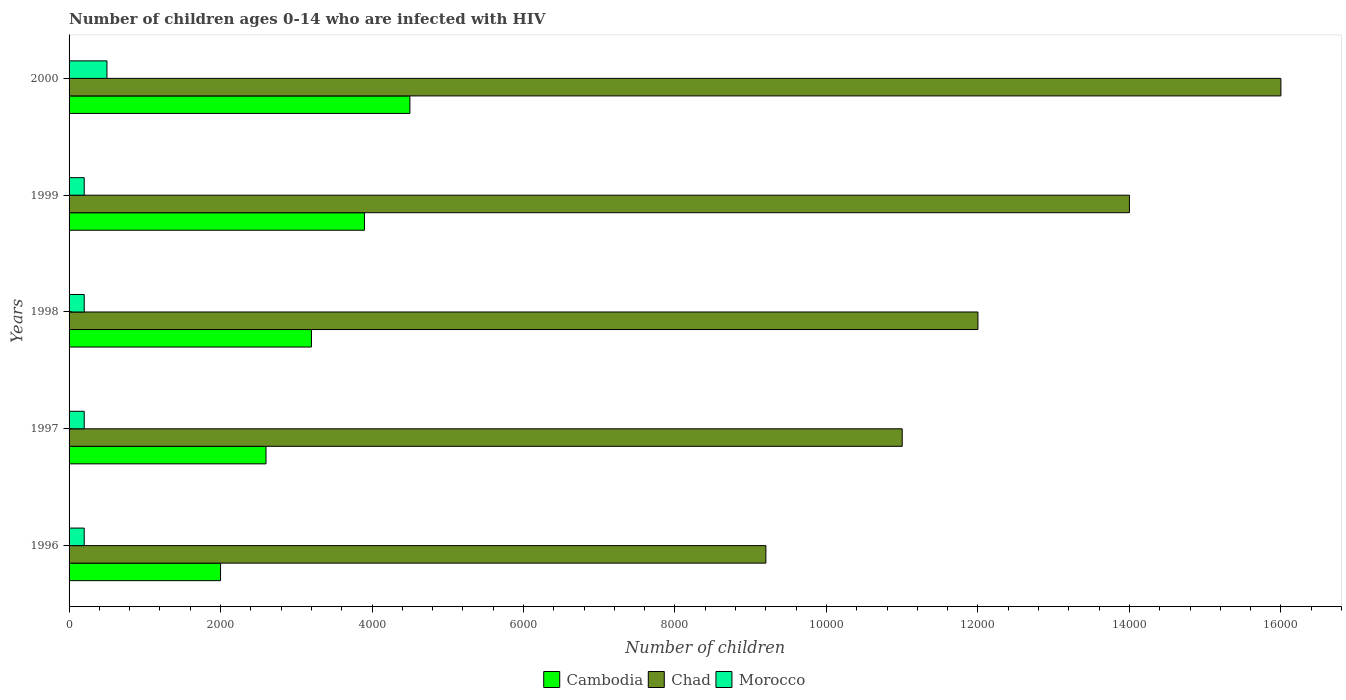How many different coloured bars are there?
Keep it short and to the point. 3. Are the number of bars per tick equal to the number of legend labels?
Ensure brevity in your answer.  Yes. How many bars are there on the 4th tick from the top?
Provide a succinct answer. 3. What is the number of HIV infected children in Morocco in 1999?
Make the answer very short. 200. Across all years, what is the maximum number of HIV infected children in Morocco?
Your response must be concise. 500. Across all years, what is the minimum number of HIV infected children in Chad?
Offer a terse response. 9200. In which year was the number of HIV infected children in Morocco maximum?
Offer a very short reply. 2000. In which year was the number of HIV infected children in Morocco minimum?
Ensure brevity in your answer.  1996. What is the total number of HIV infected children in Cambodia in the graph?
Offer a terse response. 1.62e+04. What is the difference between the number of HIV infected children in Cambodia in 1998 and that in 2000?
Keep it short and to the point. -1300. What is the difference between the number of HIV infected children in Cambodia in 1996 and the number of HIV infected children in Morocco in 2000?
Your answer should be very brief. 1500. What is the average number of HIV infected children in Cambodia per year?
Your answer should be compact. 3240. In the year 1999, what is the difference between the number of HIV infected children in Morocco and number of HIV infected children in Chad?
Your response must be concise. -1.38e+04. What is the difference between the highest and the lowest number of HIV infected children in Cambodia?
Ensure brevity in your answer.  2500. Is the sum of the number of HIV infected children in Morocco in 1998 and 1999 greater than the maximum number of HIV infected children in Cambodia across all years?
Provide a short and direct response. No. What does the 1st bar from the top in 1996 represents?
Your answer should be compact. Morocco. What does the 3rd bar from the bottom in 2000 represents?
Offer a very short reply. Morocco. What is the difference between two consecutive major ticks on the X-axis?
Your response must be concise. 2000. Are the values on the major ticks of X-axis written in scientific E-notation?
Offer a very short reply. No. Does the graph contain any zero values?
Offer a terse response. No. How many legend labels are there?
Make the answer very short. 3. How are the legend labels stacked?
Provide a succinct answer. Horizontal. What is the title of the graph?
Provide a short and direct response. Number of children ages 0-14 who are infected with HIV. What is the label or title of the X-axis?
Provide a short and direct response. Number of children. What is the Number of children of Cambodia in 1996?
Offer a very short reply. 2000. What is the Number of children of Chad in 1996?
Your response must be concise. 9200. What is the Number of children of Morocco in 1996?
Provide a short and direct response. 200. What is the Number of children of Cambodia in 1997?
Provide a succinct answer. 2600. What is the Number of children in Chad in 1997?
Your answer should be very brief. 1.10e+04. What is the Number of children of Cambodia in 1998?
Your response must be concise. 3200. What is the Number of children in Chad in 1998?
Give a very brief answer. 1.20e+04. What is the Number of children in Morocco in 1998?
Provide a short and direct response. 200. What is the Number of children in Cambodia in 1999?
Provide a succinct answer. 3900. What is the Number of children in Chad in 1999?
Your answer should be very brief. 1.40e+04. What is the Number of children of Morocco in 1999?
Offer a very short reply. 200. What is the Number of children in Cambodia in 2000?
Offer a very short reply. 4500. What is the Number of children in Chad in 2000?
Provide a short and direct response. 1.60e+04. Across all years, what is the maximum Number of children in Cambodia?
Make the answer very short. 4500. Across all years, what is the maximum Number of children of Chad?
Your answer should be very brief. 1.60e+04. Across all years, what is the minimum Number of children of Chad?
Offer a very short reply. 9200. Across all years, what is the minimum Number of children in Morocco?
Offer a terse response. 200. What is the total Number of children of Cambodia in the graph?
Offer a very short reply. 1.62e+04. What is the total Number of children of Chad in the graph?
Your response must be concise. 6.22e+04. What is the total Number of children of Morocco in the graph?
Provide a short and direct response. 1300. What is the difference between the Number of children in Cambodia in 1996 and that in 1997?
Offer a terse response. -600. What is the difference between the Number of children of Chad in 1996 and that in 1997?
Keep it short and to the point. -1800. What is the difference between the Number of children of Cambodia in 1996 and that in 1998?
Offer a very short reply. -1200. What is the difference between the Number of children of Chad in 1996 and that in 1998?
Your answer should be compact. -2800. What is the difference between the Number of children of Cambodia in 1996 and that in 1999?
Give a very brief answer. -1900. What is the difference between the Number of children in Chad in 1996 and that in 1999?
Provide a succinct answer. -4800. What is the difference between the Number of children of Cambodia in 1996 and that in 2000?
Offer a terse response. -2500. What is the difference between the Number of children of Chad in 1996 and that in 2000?
Ensure brevity in your answer.  -6800. What is the difference between the Number of children in Morocco in 1996 and that in 2000?
Provide a succinct answer. -300. What is the difference between the Number of children in Cambodia in 1997 and that in 1998?
Offer a terse response. -600. What is the difference between the Number of children of Chad in 1997 and that in 1998?
Your response must be concise. -1000. What is the difference between the Number of children of Cambodia in 1997 and that in 1999?
Your answer should be very brief. -1300. What is the difference between the Number of children of Chad in 1997 and that in 1999?
Give a very brief answer. -3000. What is the difference between the Number of children of Cambodia in 1997 and that in 2000?
Make the answer very short. -1900. What is the difference between the Number of children in Chad in 1997 and that in 2000?
Your answer should be very brief. -5000. What is the difference between the Number of children of Morocco in 1997 and that in 2000?
Offer a terse response. -300. What is the difference between the Number of children in Cambodia in 1998 and that in 1999?
Your answer should be very brief. -700. What is the difference between the Number of children of Chad in 1998 and that in 1999?
Your answer should be very brief. -2000. What is the difference between the Number of children of Morocco in 1998 and that in 1999?
Provide a succinct answer. 0. What is the difference between the Number of children of Cambodia in 1998 and that in 2000?
Your answer should be very brief. -1300. What is the difference between the Number of children of Chad in 1998 and that in 2000?
Your response must be concise. -4000. What is the difference between the Number of children of Morocco in 1998 and that in 2000?
Keep it short and to the point. -300. What is the difference between the Number of children of Cambodia in 1999 and that in 2000?
Your response must be concise. -600. What is the difference between the Number of children of Chad in 1999 and that in 2000?
Provide a succinct answer. -2000. What is the difference between the Number of children in Morocco in 1999 and that in 2000?
Offer a very short reply. -300. What is the difference between the Number of children of Cambodia in 1996 and the Number of children of Chad in 1997?
Make the answer very short. -9000. What is the difference between the Number of children in Cambodia in 1996 and the Number of children in Morocco in 1997?
Your response must be concise. 1800. What is the difference between the Number of children in Chad in 1996 and the Number of children in Morocco in 1997?
Provide a short and direct response. 9000. What is the difference between the Number of children in Cambodia in 1996 and the Number of children in Chad in 1998?
Make the answer very short. -10000. What is the difference between the Number of children in Cambodia in 1996 and the Number of children in Morocco in 1998?
Make the answer very short. 1800. What is the difference between the Number of children in Chad in 1996 and the Number of children in Morocco in 1998?
Offer a very short reply. 9000. What is the difference between the Number of children in Cambodia in 1996 and the Number of children in Chad in 1999?
Offer a terse response. -1.20e+04. What is the difference between the Number of children in Cambodia in 1996 and the Number of children in Morocco in 1999?
Ensure brevity in your answer.  1800. What is the difference between the Number of children of Chad in 1996 and the Number of children of Morocco in 1999?
Keep it short and to the point. 9000. What is the difference between the Number of children in Cambodia in 1996 and the Number of children in Chad in 2000?
Your answer should be very brief. -1.40e+04. What is the difference between the Number of children of Cambodia in 1996 and the Number of children of Morocco in 2000?
Keep it short and to the point. 1500. What is the difference between the Number of children of Chad in 1996 and the Number of children of Morocco in 2000?
Your answer should be compact. 8700. What is the difference between the Number of children of Cambodia in 1997 and the Number of children of Chad in 1998?
Your answer should be compact. -9400. What is the difference between the Number of children in Cambodia in 1997 and the Number of children in Morocco in 1998?
Give a very brief answer. 2400. What is the difference between the Number of children in Chad in 1997 and the Number of children in Morocco in 1998?
Your answer should be very brief. 1.08e+04. What is the difference between the Number of children of Cambodia in 1997 and the Number of children of Chad in 1999?
Ensure brevity in your answer.  -1.14e+04. What is the difference between the Number of children of Cambodia in 1997 and the Number of children of Morocco in 1999?
Offer a very short reply. 2400. What is the difference between the Number of children of Chad in 1997 and the Number of children of Morocco in 1999?
Provide a short and direct response. 1.08e+04. What is the difference between the Number of children of Cambodia in 1997 and the Number of children of Chad in 2000?
Your response must be concise. -1.34e+04. What is the difference between the Number of children of Cambodia in 1997 and the Number of children of Morocco in 2000?
Provide a succinct answer. 2100. What is the difference between the Number of children in Chad in 1997 and the Number of children in Morocco in 2000?
Offer a terse response. 1.05e+04. What is the difference between the Number of children of Cambodia in 1998 and the Number of children of Chad in 1999?
Your answer should be compact. -1.08e+04. What is the difference between the Number of children of Cambodia in 1998 and the Number of children of Morocco in 1999?
Make the answer very short. 3000. What is the difference between the Number of children of Chad in 1998 and the Number of children of Morocco in 1999?
Offer a very short reply. 1.18e+04. What is the difference between the Number of children of Cambodia in 1998 and the Number of children of Chad in 2000?
Provide a succinct answer. -1.28e+04. What is the difference between the Number of children in Cambodia in 1998 and the Number of children in Morocco in 2000?
Your answer should be very brief. 2700. What is the difference between the Number of children of Chad in 1998 and the Number of children of Morocco in 2000?
Your response must be concise. 1.15e+04. What is the difference between the Number of children of Cambodia in 1999 and the Number of children of Chad in 2000?
Offer a very short reply. -1.21e+04. What is the difference between the Number of children in Cambodia in 1999 and the Number of children in Morocco in 2000?
Your answer should be very brief. 3400. What is the difference between the Number of children of Chad in 1999 and the Number of children of Morocco in 2000?
Provide a short and direct response. 1.35e+04. What is the average Number of children in Cambodia per year?
Provide a short and direct response. 3240. What is the average Number of children of Chad per year?
Provide a succinct answer. 1.24e+04. What is the average Number of children of Morocco per year?
Offer a very short reply. 260. In the year 1996, what is the difference between the Number of children of Cambodia and Number of children of Chad?
Provide a succinct answer. -7200. In the year 1996, what is the difference between the Number of children in Cambodia and Number of children in Morocco?
Give a very brief answer. 1800. In the year 1996, what is the difference between the Number of children in Chad and Number of children in Morocco?
Your response must be concise. 9000. In the year 1997, what is the difference between the Number of children in Cambodia and Number of children in Chad?
Give a very brief answer. -8400. In the year 1997, what is the difference between the Number of children in Cambodia and Number of children in Morocco?
Provide a succinct answer. 2400. In the year 1997, what is the difference between the Number of children in Chad and Number of children in Morocco?
Your response must be concise. 1.08e+04. In the year 1998, what is the difference between the Number of children in Cambodia and Number of children in Chad?
Offer a very short reply. -8800. In the year 1998, what is the difference between the Number of children in Cambodia and Number of children in Morocco?
Make the answer very short. 3000. In the year 1998, what is the difference between the Number of children in Chad and Number of children in Morocco?
Offer a terse response. 1.18e+04. In the year 1999, what is the difference between the Number of children in Cambodia and Number of children in Chad?
Offer a terse response. -1.01e+04. In the year 1999, what is the difference between the Number of children of Cambodia and Number of children of Morocco?
Keep it short and to the point. 3700. In the year 1999, what is the difference between the Number of children in Chad and Number of children in Morocco?
Ensure brevity in your answer.  1.38e+04. In the year 2000, what is the difference between the Number of children of Cambodia and Number of children of Chad?
Your answer should be very brief. -1.15e+04. In the year 2000, what is the difference between the Number of children of Cambodia and Number of children of Morocco?
Provide a short and direct response. 4000. In the year 2000, what is the difference between the Number of children in Chad and Number of children in Morocco?
Your response must be concise. 1.55e+04. What is the ratio of the Number of children of Cambodia in 1996 to that in 1997?
Provide a succinct answer. 0.77. What is the ratio of the Number of children in Chad in 1996 to that in 1997?
Keep it short and to the point. 0.84. What is the ratio of the Number of children of Morocco in 1996 to that in 1997?
Your answer should be very brief. 1. What is the ratio of the Number of children in Cambodia in 1996 to that in 1998?
Make the answer very short. 0.62. What is the ratio of the Number of children in Chad in 1996 to that in 1998?
Provide a succinct answer. 0.77. What is the ratio of the Number of children of Cambodia in 1996 to that in 1999?
Give a very brief answer. 0.51. What is the ratio of the Number of children of Chad in 1996 to that in 1999?
Ensure brevity in your answer.  0.66. What is the ratio of the Number of children of Cambodia in 1996 to that in 2000?
Offer a very short reply. 0.44. What is the ratio of the Number of children of Chad in 1996 to that in 2000?
Keep it short and to the point. 0.57. What is the ratio of the Number of children in Cambodia in 1997 to that in 1998?
Your answer should be compact. 0.81. What is the ratio of the Number of children of Chad in 1997 to that in 1999?
Your answer should be compact. 0.79. What is the ratio of the Number of children of Morocco in 1997 to that in 1999?
Provide a short and direct response. 1. What is the ratio of the Number of children in Cambodia in 1997 to that in 2000?
Your answer should be compact. 0.58. What is the ratio of the Number of children of Chad in 1997 to that in 2000?
Make the answer very short. 0.69. What is the ratio of the Number of children in Morocco in 1997 to that in 2000?
Offer a terse response. 0.4. What is the ratio of the Number of children of Cambodia in 1998 to that in 1999?
Provide a succinct answer. 0.82. What is the ratio of the Number of children in Chad in 1998 to that in 1999?
Your response must be concise. 0.86. What is the ratio of the Number of children of Cambodia in 1998 to that in 2000?
Provide a short and direct response. 0.71. What is the ratio of the Number of children in Morocco in 1998 to that in 2000?
Ensure brevity in your answer.  0.4. What is the ratio of the Number of children of Cambodia in 1999 to that in 2000?
Offer a very short reply. 0.87. What is the ratio of the Number of children in Morocco in 1999 to that in 2000?
Provide a succinct answer. 0.4. What is the difference between the highest and the second highest Number of children of Cambodia?
Provide a short and direct response. 600. What is the difference between the highest and the second highest Number of children in Morocco?
Keep it short and to the point. 300. What is the difference between the highest and the lowest Number of children of Cambodia?
Provide a short and direct response. 2500. What is the difference between the highest and the lowest Number of children of Chad?
Provide a succinct answer. 6800. What is the difference between the highest and the lowest Number of children in Morocco?
Make the answer very short. 300. 